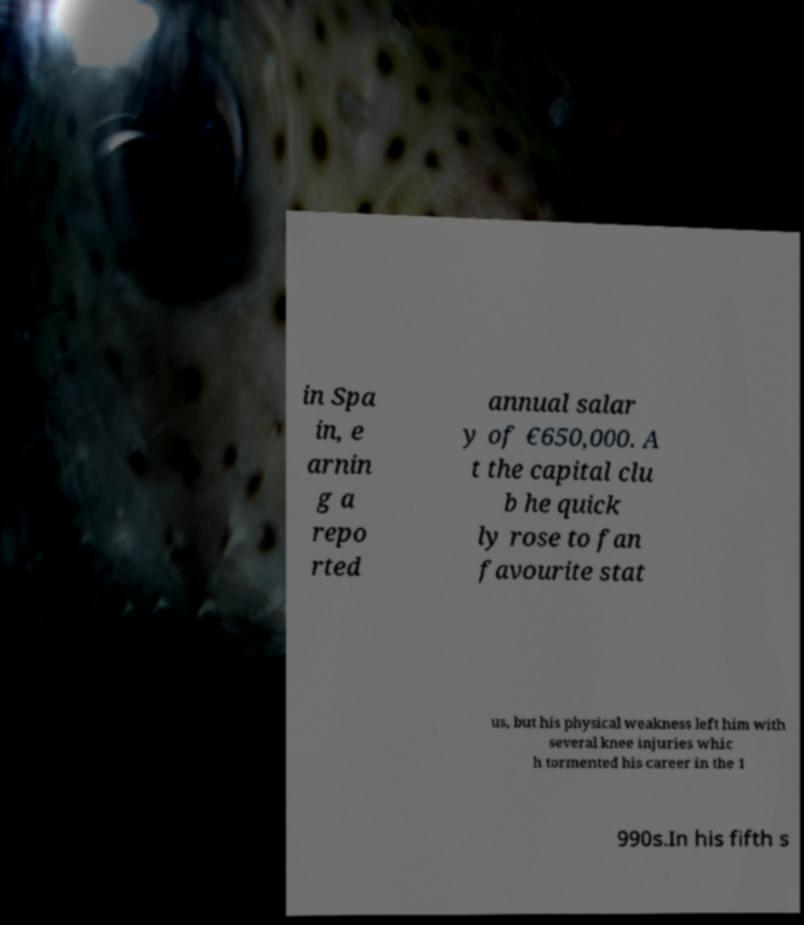Please identify and transcribe the text found in this image. in Spa in, e arnin g a repo rted annual salar y of €650,000. A t the capital clu b he quick ly rose to fan favourite stat us, but his physical weakness left him with several knee injuries whic h tormented his career in the 1 990s.In his fifth s 